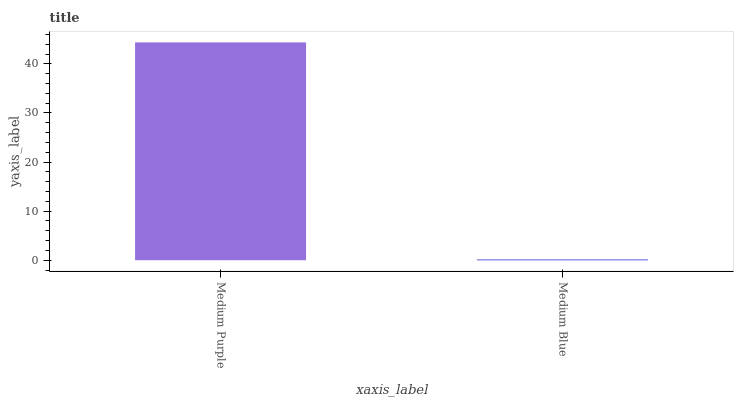Is Medium Blue the minimum?
Answer yes or no. Yes. Is Medium Purple the maximum?
Answer yes or no. Yes. Is Medium Blue the maximum?
Answer yes or no. No. Is Medium Purple greater than Medium Blue?
Answer yes or no. Yes. Is Medium Blue less than Medium Purple?
Answer yes or no. Yes. Is Medium Blue greater than Medium Purple?
Answer yes or no. No. Is Medium Purple less than Medium Blue?
Answer yes or no. No. Is Medium Purple the high median?
Answer yes or no. Yes. Is Medium Blue the low median?
Answer yes or no. Yes. Is Medium Blue the high median?
Answer yes or no. No. Is Medium Purple the low median?
Answer yes or no. No. 